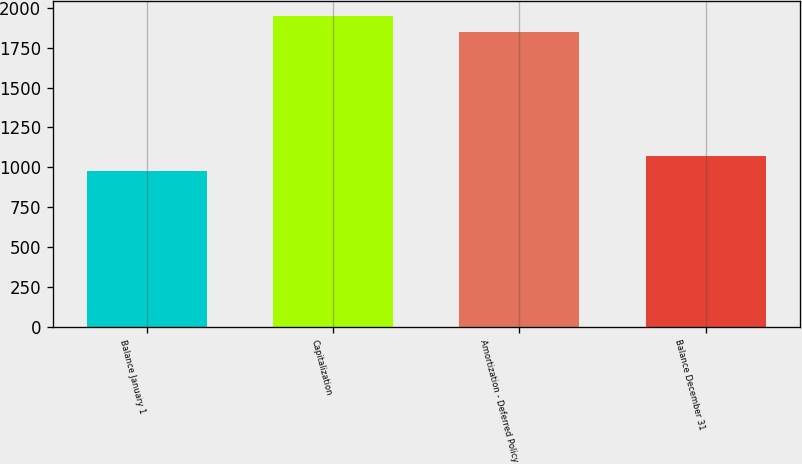Convert chart. <chart><loc_0><loc_0><loc_500><loc_500><bar_chart><fcel>Balance January 1<fcel>Capitalization<fcel>Amortization - Deferred Policy<fcel>Balance December 31<nl><fcel>975<fcel>1947.1<fcel>1850<fcel>1072.1<nl></chart> 